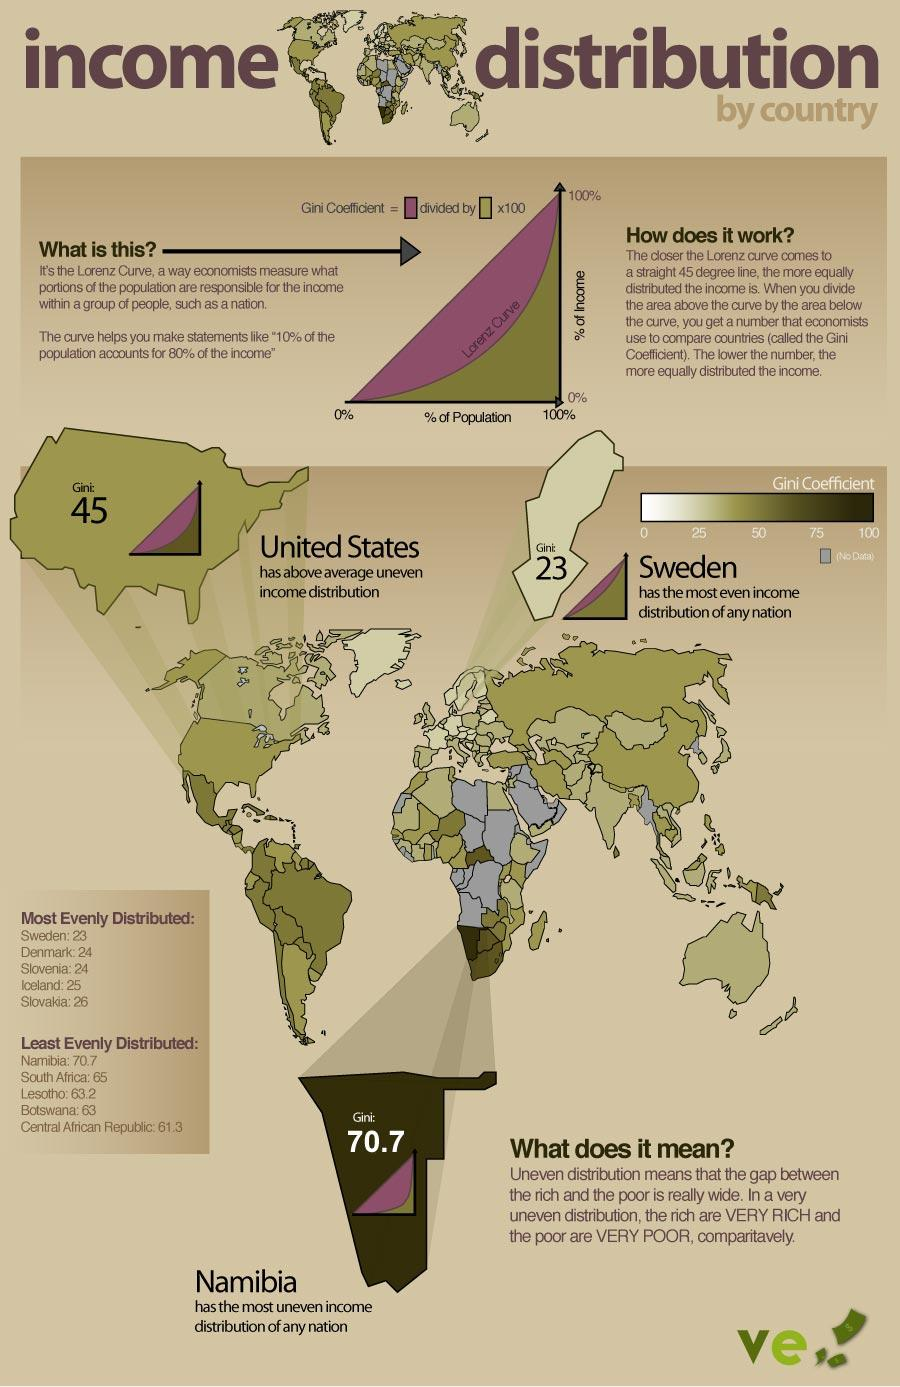Give some essential details in this illustration. According to the Gini coefficient, Denmark and Slovenia share the distinction of having a score of 24, indicating a moderate level of income inequality. Namibia has the highest Gini score among all countries. 